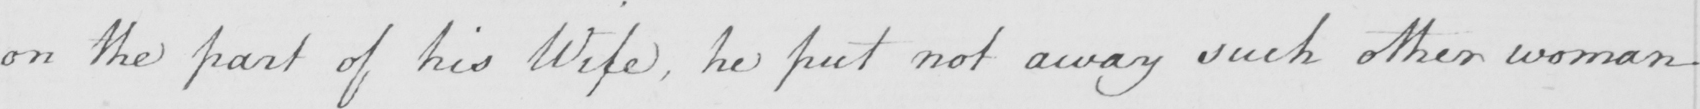Please provide the text content of this handwritten line. on the part of his Wife , he put not away such other woman 